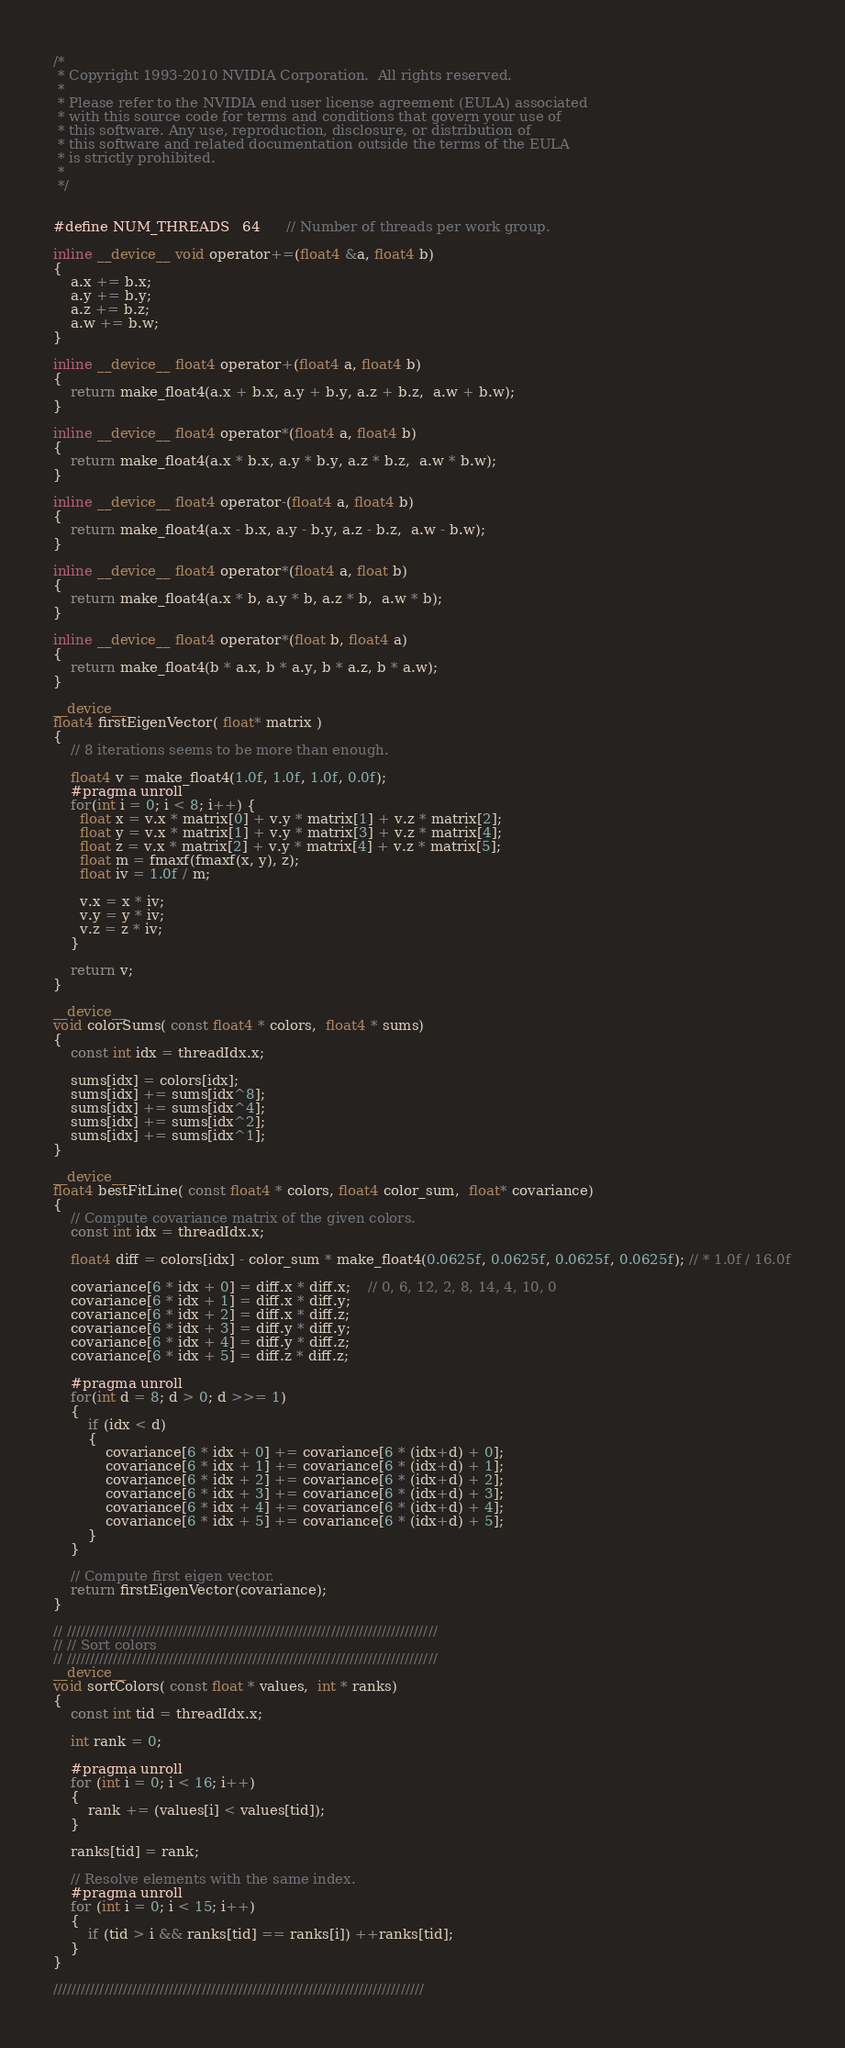<code> <loc_0><loc_0><loc_500><loc_500><_Cuda_>/*
 * Copyright 1993-2010 NVIDIA Corporation.  All rights reserved.
 *
 * Please refer to the NVIDIA end user license agreement (EULA) associated
 * with this source code for terms and conditions that govern your use of
 * this software. Any use, reproduction, disclosure, or distribution of
 * this software and related documentation outside the terms of the EULA
 * is strictly prohibited.
 *
 */
 

#define NUM_THREADS   64      // Number of threads per work group.

inline __device__ void operator+=(float4 &a, float4 b)
{
    a.x += b.x;
    a.y += b.y;
    a.z += b.z;
    a.w += b.w;
}

inline __device__ float4 operator+(float4 a, float4 b)
{
    return make_float4(a.x + b.x, a.y + b.y, a.z + b.z,  a.w + b.w);
}

inline __device__ float4 operator*(float4 a, float4 b)
{
    return make_float4(a.x * b.x, a.y * b.y, a.z * b.z,  a.w * b.w);
}

inline __device__ float4 operator-(float4 a, float4 b)
{
    return make_float4(a.x - b.x, a.y - b.y, a.z - b.z,  a.w - b.w);
}

inline __device__ float4 operator*(float4 a, float b)
{
    return make_float4(a.x * b, a.y * b, a.z * b,  a.w * b);
}

inline __device__ float4 operator*(float b, float4 a)
{
    return make_float4(b * a.x, b * a.y, b * a.z, b * a.w);
}

__device__
float4 firstEigenVector( float* matrix )
{
    // 8 iterations seems to be more than enough.

    float4 v = make_float4(1.0f, 1.0f, 1.0f, 0.0f);
    #pragma unroll
    for(int i = 0; i < 8; i++) {
      float x = v.x * matrix[0] + v.y * matrix[1] + v.z * matrix[2];
      float y = v.x * matrix[1] + v.y * matrix[3] + v.z * matrix[4];
      float z = v.x * matrix[2] + v.y * matrix[4] + v.z * matrix[5];
      float m = fmaxf(fmaxf(x, y), z);        
      float iv = 1.0f / m;
      
      v.x = x * iv;
      v.y = y * iv;
      v.z = z * iv;      
    }

    return v;
}

__device__
void colorSums( const float4 * colors,  float4 * sums)
{
    const int idx = threadIdx.x;

    sums[idx] = colors[idx];
    sums[idx] += sums[idx^8];
    sums[idx] += sums[idx^4];
    sums[idx] += sums[idx^2];
    sums[idx] += sums[idx^1];
}

__device__
float4 bestFitLine( const float4 * colors, float4 color_sum,  float* covariance)
{
    // Compute covariance matrix of the given colors.
    const int idx = threadIdx.x;

    float4 diff = colors[idx] - color_sum * make_float4(0.0625f, 0.0625f, 0.0625f, 0.0625f); // * 1.0f / 16.0f

    covariance[6 * idx + 0] = diff.x * diff.x;    // 0, 6, 12, 2, 8, 14, 4, 10, 0
    covariance[6 * idx + 1] = diff.x * diff.y;
    covariance[6 * idx + 2] = diff.x * diff.z;
    covariance[6 * idx + 3] = diff.y * diff.y;
    covariance[6 * idx + 4] = diff.y * diff.z;
    covariance[6 * idx + 5] = diff.z * diff.z;

    #pragma unroll
    for(int d = 8; d > 0; d >>= 1)
    {
        if (idx < d)
        {
            covariance[6 * idx + 0] += covariance[6 * (idx+d) + 0];
            covariance[6 * idx + 1] += covariance[6 * (idx+d) + 1];
            covariance[6 * idx + 2] += covariance[6 * (idx+d) + 2];
            covariance[6 * idx + 3] += covariance[6 * (idx+d) + 3];
            covariance[6 * idx + 4] += covariance[6 * (idx+d) + 4];
            covariance[6 * idx + 5] += covariance[6 * (idx+d) + 5];
        }
    }

    // Compute first eigen vector.
    return firstEigenVector(covariance);
}

// ////////////////////////////////////////////////////////////////////////////////
// // Sort colors
// ////////////////////////////////////////////////////////////////////////////////
__device__
void sortColors( const float * values,  int * ranks)
{
    const int tid = threadIdx.x;

    int rank = 0;

    #pragma unroll
    for (int i = 0; i < 16; i++)
    {
        rank += (values[i] < values[tid]);
    }
    
    ranks[tid] = rank;

    // Resolve elements with the same index.
    #pragma unroll
    for (int i = 0; i < 15; i++)
    {
        if (tid > i && ranks[tid] == ranks[i]) ++ranks[tid];
    }
}

////////////////////////////////////////////////////////////////////////////////</code> 